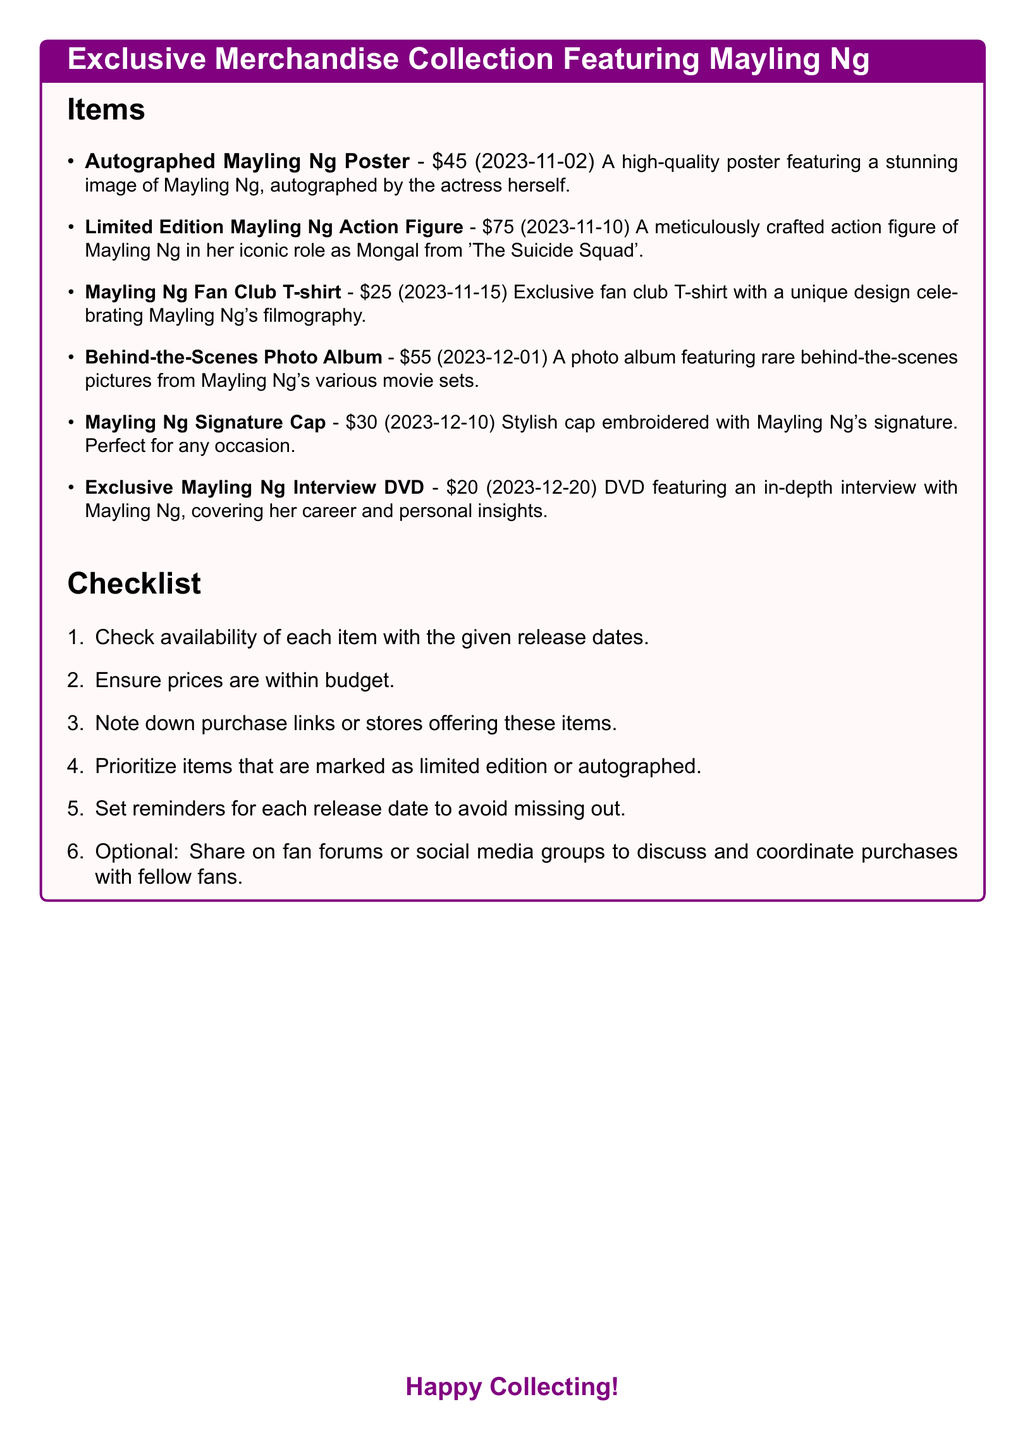What is the price of the Autographed Mayling Ng Poster? The price can be found next to the item description.
Answer: $45 When will the Limited Edition Mayling Ng Action Figure be released? The release date is provided in parentheses after the item title.
Answer: 2023-11-10 How much does the Mayling Ng Fan Club T-shirt cost? The cost is indicated next to the item in the document.
Answer: $25 Which item features behind-the-scenes pictures? This can be identified by reading the descriptions of each item.
Answer: Behind-the-Scenes Photo Album What is the total cost of all items listed? The total is calculated by summing up the prices of each merchandise item.
Answer: $320 Which item is marked as limited edition? The specific item description will indicate any limited edition status.
Answer: Limited Edition Mayling Ng Action Figure What should you prioritize when purchasing items? This is based on the guidance given in the checklist section of the document.
Answer: Limited edition or autographed items How many days are there until the release of the Signature Cap? This requires calculating the time from the current date to the release date.
Answer: 30 days When is the release date for the Exclusive Mayling Ng Interview DVD? This can be found directly from the item's information in the document.
Answer: 2023-12-20 